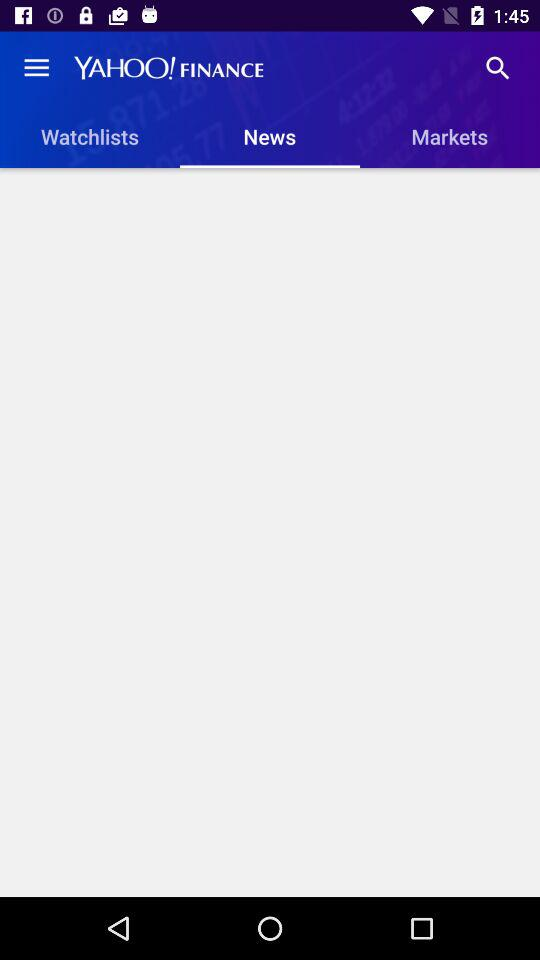What is the application name? The application name is "YAHOO! FINANCE". 